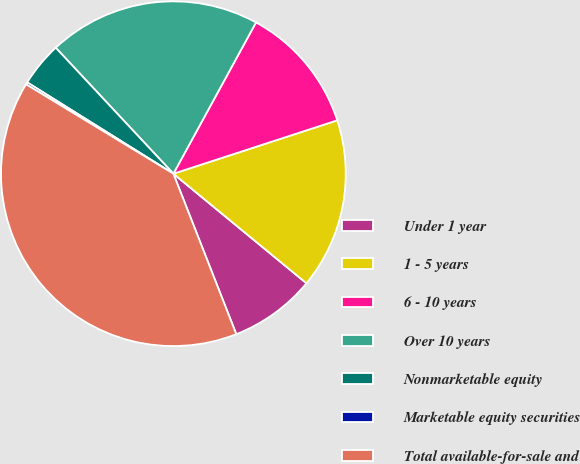Convert chart. <chart><loc_0><loc_0><loc_500><loc_500><pie_chart><fcel>Under 1 year<fcel>1 - 5 years<fcel>6 - 10 years<fcel>Over 10 years<fcel>Nonmarketable equity<fcel>Marketable equity securities<fcel>Total available-for-sale and<nl><fcel>8.09%<fcel>15.97%<fcel>12.03%<fcel>19.91%<fcel>4.15%<fcel>0.21%<fcel>39.62%<nl></chart> 